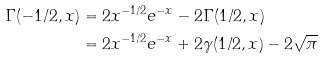Convert formula to latex. <formula><loc_0><loc_0><loc_500><loc_500>\Gamma ( - 1 / 2 , x ) & = 2 x ^ { - 1 / 2 } e ^ { - x } - 2 \Gamma ( 1 / 2 , x ) \\ & = 2 x ^ { - 1 / 2 } e ^ { - x } + 2 \gamma ( 1 / 2 , x ) - 2 \sqrt { \pi }</formula> 